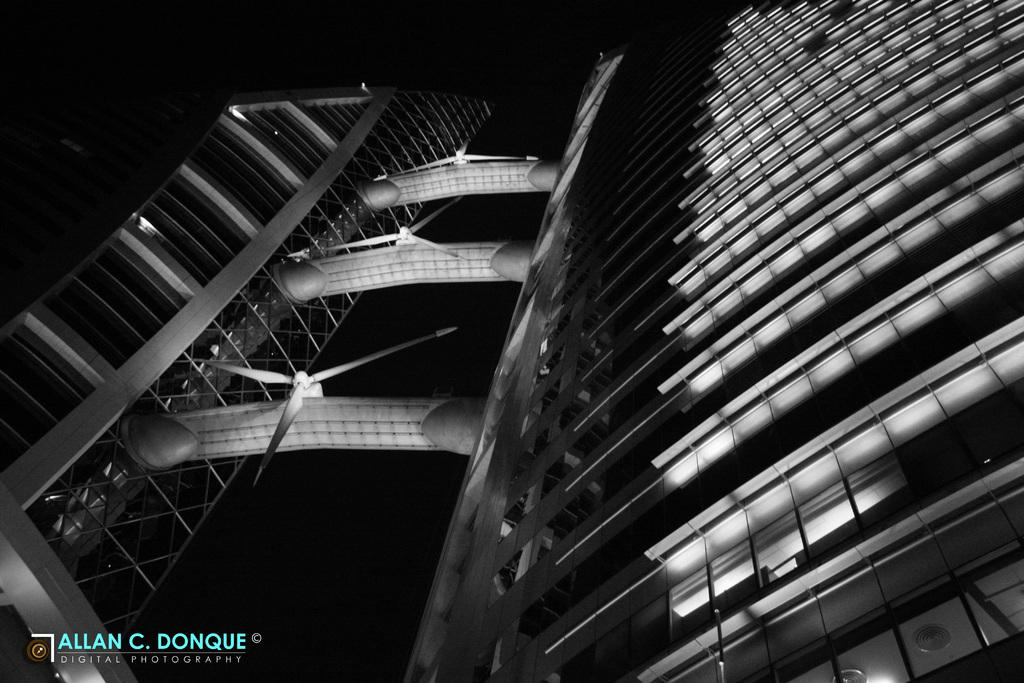What is the main subject of the image? The main subject of the image is a building. How many apples are hanging from the building in the image? There are no apples present in the image, as it features a building. What process is being carried out in the building in the image? The image does not provide any information about a process being carried out inside the building. 